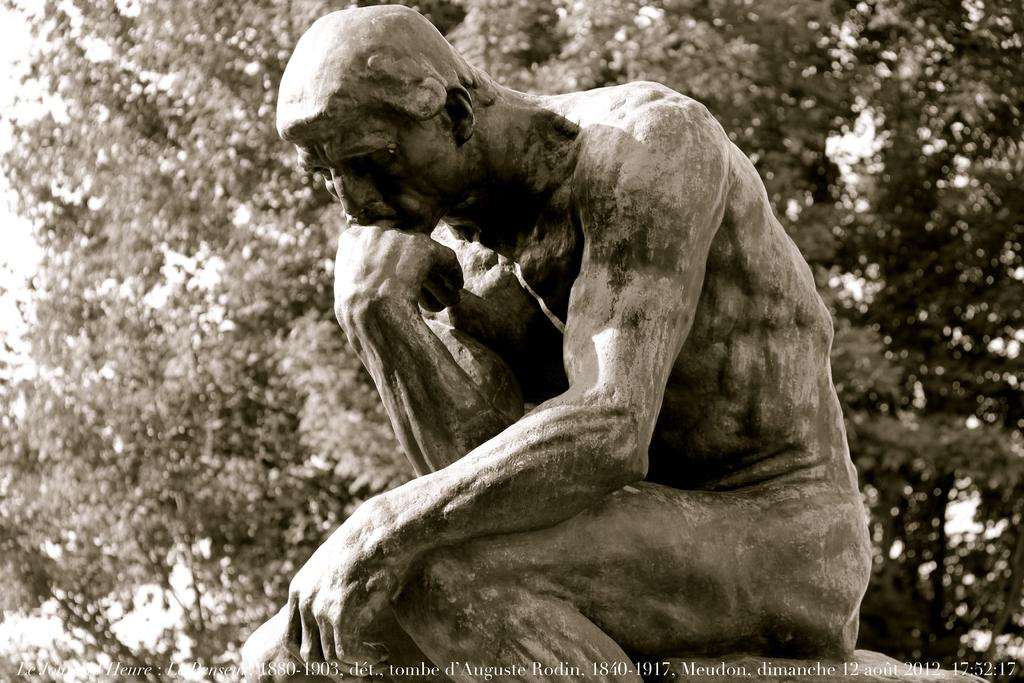What is the main subject of the image? There is a sculpture in the image. What can be seen in the background of the image? There are trees in the background of the image. Is there any additional information about the image itself? Yes, there is a watermark on the bottom side of the image. What type of punishment is being depicted in the sculpture? There is no punishment being depicted in the sculpture; it is a sculpture and not a scene or event. 